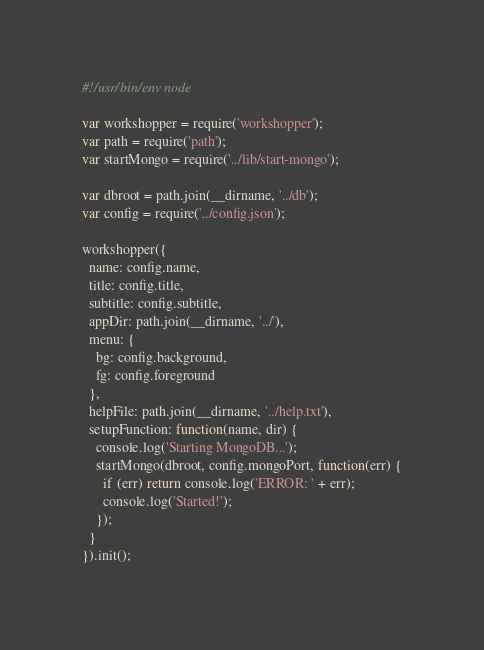<code> <loc_0><loc_0><loc_500><loc_500><_JavaScript_>#!/usr/bin/env node

var workshopper = require('workshopper');
var path = require('path');
var startMongo = require('../lib/start-mongo');

var dbroot = path.join(__dirname, '../db');
var config = require('../config.json');

workshopper({
  name: config.name,
  title: config.title,
  subtitle: config.subtitle,
  appDir: path.join(__dirname, '../'),
  menu: {
    bg: config.background,
    fg: config.foreground
  },
  helpFile: path.join(__dirname, '../help.txt'),
  setupFunction: function(name, dir) {
    console.log('Starting MongoDB...');
    startMongo(dbroot, config.mongoPort, function(err) {
      if (err) return console.log('ERROR: ' + err);
      console.log('Started!');
    });
  }
}).init();</code> 